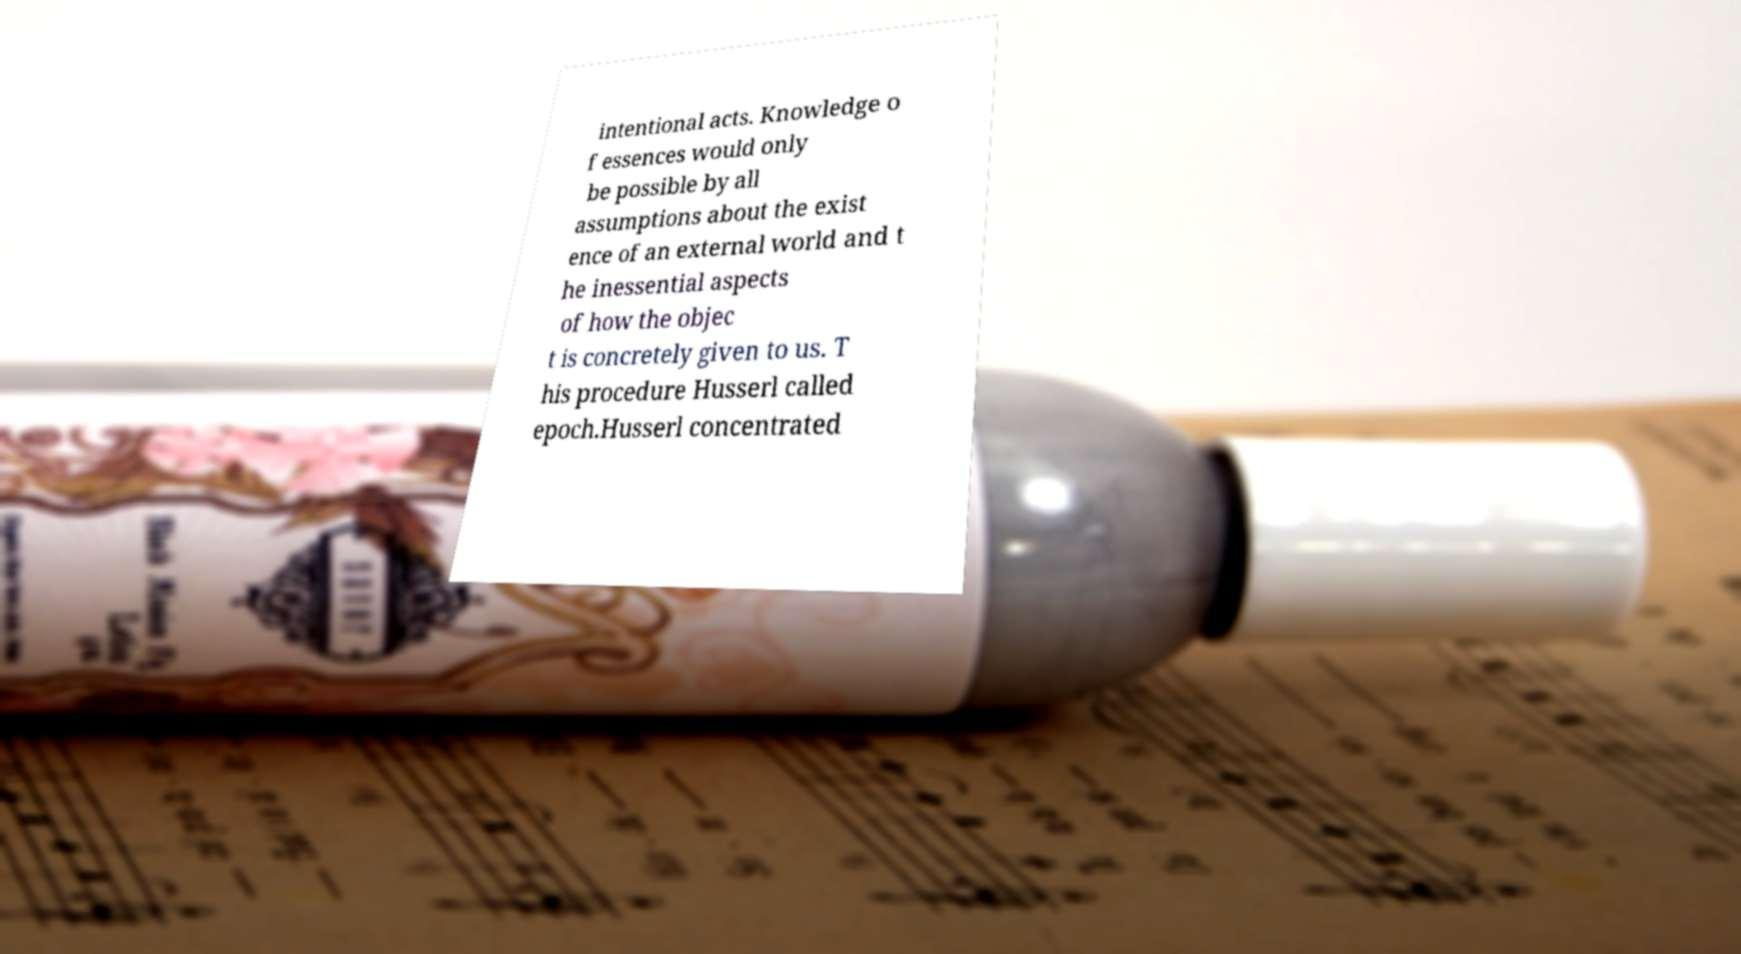Could you extract and type out the text from this image? intentional acts. Knowledge o f essences would only be possible by all assumptions about the exist ence of an external world and t he inessential aspects of how the objec t is concretely given to us. T his procedure Husserl called epoch.Husserl concentrated 